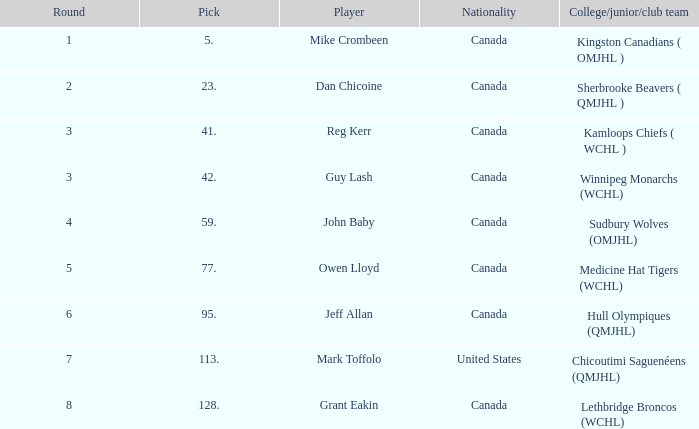For which college, junior, or club team is there a round of 2? Sherbrooke Beavers ( QMJHL ). 